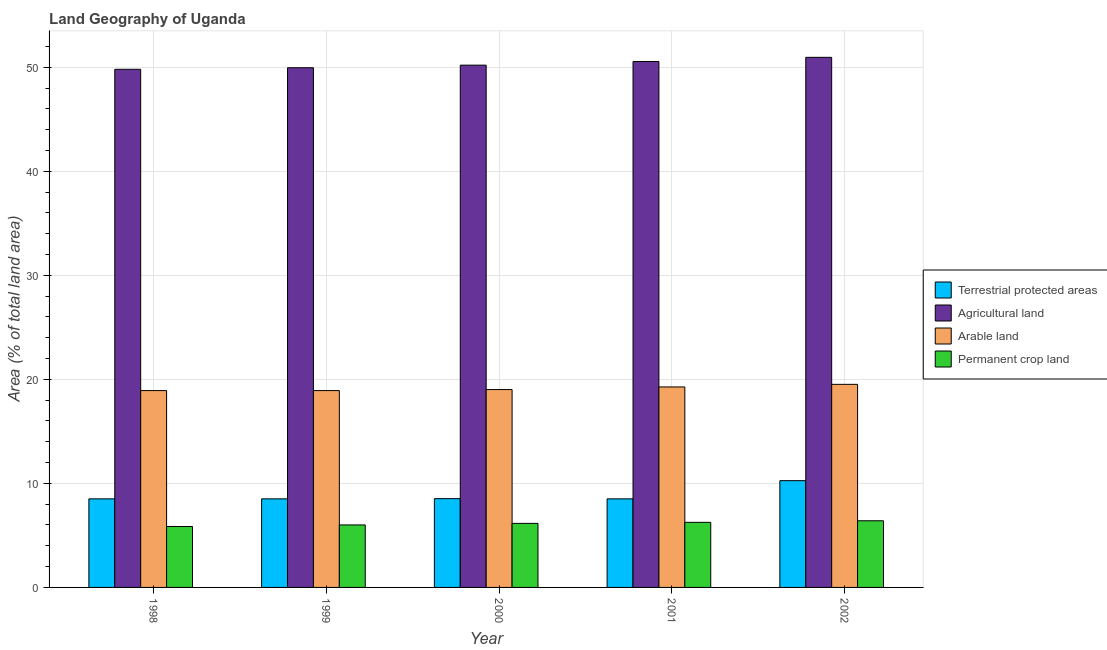How many different coloured bars are there?
Provide a short and direct response. 4. How many groups of bars are there?
Offer a very short reply. 5. Are the number of bars per tick equal to the number of legend labels?
Your answer should be very brief. Yes. How many bars are there on the 3rd tick from the left?
Keep it short and to the point. 4. How many bars are there on the 1st tick from the right?
Provide a short and direct response. 4. In how many cases, is the number of bars for a given year not equal to the number of legend labels?
Offer a very short reply. 0. What is the percentage of area under agricultural land in 2002?
Give a very brief answer. 50.95. Across all years, what is the maximum percentage of land under terrestrial protection?
Provide a succinct answer. 10.26. Across all years, what is the minimum percentage of area under agricultural land?
Keep it short and to the point. 49.8. What is the total percentage of area under permanent crop land in the graph?
Make the answer very short. 30.68. What is the difference between the percentage of land under terrestrial protection in 1998 and that in 2002?
Provide a succinct answer. -1.75. What is the difference between the percentage of land under terrestrial protection in 2001 and the percentage of area under agricultural land in 2000?
Your response must be concise. -0.02. What is the average percentage of area under arable land per year?
Provide a succinct answer. 19.13. In the year 2001, what is the difference between the percentage of area under permanent crop land and percentage of area under arable land?
Give a very brief answer. 0. What is the ratio of the percentage of land under terrestrial protection in 1998 to that in 1999?
Your response must be concise. 1. What is the difference between the highest and the second highest percentage of land under terrestrial protection?
Offer a terse response. 1.73. What is the difference between the highest and the lowest percentage of land under terrestrial protection?
Offer a terse response. 1.75. What does the 3rd bar from the left in 2000 represents?
Ensure brevity in your answer.  Arable land. What does the 3rd bar from the right in 2000 represents?
Give a very brief answer. Agricultural land. Are all the bars in the graph horizontal?
Make the answer very short. No. What is the difference between two consecutive major ticks on the Y-axis?
Offer a very short reply. 10. Does the graph contain any zero values?
Offer a very short reply. No. Does the graph contain grids?
Give a very brief answer. Yes. What is the title of the graph?
Ensure brevity in your answer.  Land Geography of Uganda. What is the label or title of the X-axis?
Make the answer very short. Year. What is the label or title of the Y-axis?
Your answer should be compact. Area (% of total land area). What is the Area (% of total land area) in Terrestrial protected areas in 1998?
Make the answer very short. 8.51. What is the Area (% of total land area) in Agricultural land in 1998?
Offer a terse response. 49.8. What is the Area (% of total land area) in Arable land in 1998?
Provide a short and direct response. 18.92. What is the Area (% of total land area) of Permanent crop land in 1998?
Ensure brevity in your answer.  5.86. What is the Area (% of total land area) of Terrestrial protected areas in 1999?
Offer a very short reply. 8.51. What is the Area (% of total land area) in Agricultural land in 1999?
Give a very brief answer. 49.95. What is the Area (% of total land area) of Arable land in 1999?
Offer a very short reply. 18.92. What is the Area (% of total land area) of Permanent crop land in 1999?
Your answer should be very brief. 6.01. What is the Area (% of total land area) of Terrestrial protected areas in 2000?
Keep it short and to the point. 8.53. What is the Area (% of total land area) in Agricultural land in 2000?
Provide a succinct answer. 50.2. What is the Area (% of total land area) of Arable land in 2000?
Your answer should be compact. 19.02. What is the Area (% of total land area) of Permanent crop land in 2000?
Offer a terse response. 6.16. What is the Area (% of total land area) in Terrestrial protected areas in 2001?
Keep it short and to the point. 8.51. What is the Area (% of total land area) in Agricultural land in 2001?
Provide a short and direct response. 50.55. What is the Area (% of total land area) of Arable land in 2001?
Your answer should be very brief. 19.27. What is the Area (% of total land area) in Permanent crop land in 2001?
Keep it short and to the point. 6.26. What is the Area (% of total land area) of Terrestrial protected areas in 2002?
Your answer should be very brief. 10.26. What is the Area (% of total land area) in Agricultural land in 2002?
Provide a short and direct response. 50.95. What is the Area (% of total land area) of Arable land in 2002?
Keep it short and to the point. 19.52. What is the Area (% of total land area) in Permanent crop land in 2002?
Ensure brevity in your answer.  6.41. Across all years, what is the maximum Area (% of total land area) in Terrestrial protected areas?
Your answer should be compact. 10.26. Across all years, what is the maximum Area (% of total land area) in Agricultural land?
Provide a succinct answer. 50.95. Across all years, what is the maximum Area (% of total land area) in Arable land?
Provide a succinct answer. 19.52. Across all years, what is the maximum Area (% of total land area) in Permanent crop land?
Give a very brief answer. 6.41. Across all years, what is the minimum Area (% of total land area) of Terrestrial protected areas?
Ensure brevity in your answer.  8.51. Across all years, what is the minimum Area (% of total land area) of Agricultural land?
Offer a terse response. 49.8. Across all years, what is the minimum Area (% of total land area) of Arable land?
Provide a short and direct response. 18.92. Across all years, what is the minimum Area (% of total land area) of Permanent crop land?
Your answer should be compact. 5.86. What is the total Area (% of total land area) in Terrestrial protected areas in the graph?
Your answer should be very brief. 44.33. What is the total Area (% of total land area) of Agricultural land in the graph?
Offer a very short reply. 251.44. What is the total Area (% of total land area) in Arable land in the graph?
Offer a very short reply. 95.64. What is the total Area (% of total land area) of Permanent crop land in the graph?
Offer a very short reply. 30.68. What is the difference between the Area (% of total land area) in Terrestrial protected areas in 1998 and that in 1999?
Offer a very short reply. 0. What is the difference between the Area (% of total land area) in Agricultural land in 1998 and that in 1999?
Make the answer very short. -0.15. What is the difference between the Area (% of total land area) in Arable land in 1998 and that in 1999?
Your response must be concise. 0. What is the difference between the Area (% of total land area) in Permanent crop land in 1998 and that in 1999?
Make the answer very short. -0.15. What is the difference between the Area (% of total land area) in Terrestrial protected areas in 1998 and that in 2000?
Keep it short and to the point. -0.02. What is the difference between the Area (% of total land area) of Agricultural land in 1998 and that in 2000?
Offer a very short reply. -0.4. What is the difference between the Area (% of total land area) of Arable land in 1998 and that in 2000?
Your answer should be compact. -0.1. What is the difference between the Area (% of total land area) in Permanent crop land in 1998 and that in 2000?
Provide a succinct answer. -0.3. What is the difference between the Area (% of total land area) in Agricultural land in 1998 and that in 2001?
Give a very brief answer. -0.75. What is the difference between the Area (% of total land area) of Arable land in 1998 and that in 2001?
Provide a succinct answer. -0.35. What is the difference between the Area (% of total land area) in Permanent crop land in 1998 and that in 2001?
Give a very brief answer. -0.4. What is the difference between the Area (% of total land area) in Terrestrial protected areas in 1998 and that in 2002?
Make the answer very short. -1.75. What is the difference between the Area (% of total land area) in Agricultural land in 1998 and that in 2002?
Your answer should be very brief. -1.15. What is the difference between the Area (% of total land area) of Arable land in 1998 and that in 2002?
Make the answer very short. -0.6. What is the difference between the Area (% of total land area) of Permanent crop land in 1998 and that in 2002?
Make the answer very short. -0.55. What is the difference between the Area (% of total land area) in Terrestrial protected areas in 1999 and that in 2000?
Give a very brief answer. -0.02. What is the difference between the Area (% of total land area) in Agricultural land in 1999 and that in 2000?
Ensure brevity in your answer.  -0.25. What is the difference between the Area (% of total land area) in Arable land in 1999 and that in 2000?
Provide a succinct answer. -0.1. What is the difference between the Area (% of total land area) in Permanent crop land in 1999 and that in 2000?
Your answer should be compact. -0.15. What is the difference between the Area (% of total land area) of Terrestrial protected areas in 1999 and that in 2001?
Ensure brevity in your answer.  0. What is the difference between the Area (% of total land area) of Agricultural land in 1999 and that in 2001?
Your answer should be very brief. -0.6. What is the difference between the Area (% of total land area) in Arable land in 1999 and that in 2001?
Your answer should be very brief. -0.35. What is the difference between the Area (% of total land area) in Permanent crop land in 1999 and that in 2001?
Provide a succinct answer. -0.25. What is the difference between the Area (% of total land area) in Terrestrial protected areas in 1999 and that in 2002?
Your answer should be very brief. -1.75. What is the difference between the Area (% of total land area) of Agricultural land in 1999 and that in 2002?
Offer a terse response. -1. What is the difference between the Area (% of total land area) in Arable land in 1999 and that in 2002?
Provide a succinct answer. -0.6. What is the difference between the Area (% of total land area) of Permanent crop land in 1999 and that in 2002?
Your response must be concise. -0.4. What is the difference between the Area (% of total land area) in Terrestrial protected areas in 2000 and that in 2001?
Give a very brief answer. 0.02. What is the difference between the Area (% of total land area) of Agricultural land in 2000 and that in 2001?
Your answer should be very brief. -0.35. What is the difference between the Area (% of total land area) in Arable land in 2000 and that in 2001?
Provide a succinct answer. -0.25. What is the difference between the Area (% of total land area) of Permanent crop land in 2000 and that in 2001?
Your answer should be very brief. -0.1. What is the difference between the Area (% of total land area) in Terrestrial protected areas in 2000 and that in 2002?
Offer a very short reply. -1.73. What is the difference between the Area (% of total land area) in Agricultural land in 2000 and that in 2002?
Provide a short and direct response. -0.75. What is the difference between the Area (% of total land area) of Arable land in 2000 and that in 2002?
Provide a short and direct response. -0.5. What is the difference between the Area (% of total land area) in Permanent crop land in 2000 and that in 2002?
Make the answer very short. -0.25. What is the difference between the Area (% of total land area) of Terrestrial protected areas in 2001 and that in 2002?
Give a very brief answer. -1.75. What is the difference between the Area (% of total land area) in Agricultural land in 2001 and that in 2002?
Your answer should be compact. -0.4. What is the difference between the Area (% of total land area) of Arable land in 2001 and that in 2002?
Offer a very short reply. -0.25. What is the difference between the Area (% of total land area) of Permanent crop land in 2001 and that in 2002?
Give a very brief answer. -0.15. What is the difference between the Area (% of total land area) of Terrestrial protected areas in 1998 and the Area (% of total land area) of Agricultural land in 1999?
Your answer should be very brief. -41.43. What is the difference between the Area (% of total land area) in Terrestrial protected areas in 1998 and the Area (% of total land area) in Arable land in 1999?
Offer a terse response. -10.4. What is the difference between the Area (% of total land area) of Terrestrial protected areas in 1998 and the Area (% of total land area) of Permanent crop land in 1999?
Keep it short and to the point. 2.51. What is the difference between the Area (% of total land area) in Agricultural land in 1998 and the Area (% of total land area) in Arable land in 1999?
Offer a very short reply. 30.88. What is the difference between the Area (% of total land area) in Agricultural land in 1998 and the Area (% of total land area) in Permanent crop land in 1999?
Your answer should be very brief. 43.79. What is the difference between the Area (% of total land area) of Arable land in 1998 and the Area (% of total land area) of Permanent crop land in 1999?
Your answer should be compact. 12.91. What is the difference between the Area (% of total land area) of Terrestrial protected areas in 1998 and the Area (% of total land area) of Agricultural land in 2000?
Your response must be concise. -41.68. What is the difference between the Area (% of total land area) of Terrestrial protected areas in 1998 and the Area (% of total land area) of Arable land in 2000?
Offer a terse response. -10.51. What is the difference between the Area (% of total land area) in Terrestrial protected areas in 1998 and the Area (% of total land area) in Permanent crop land in 2000?
Your answer should be compact. 2.36. What is the difference between the Area (% of total land area) in Agricultural land in 1998 and the Area (% of total land area) in Arable land in 2000?
Keep it short and to the point. 30.78. What is the difference between the Area (% of total land area) of Agricultural land in 1998 and the Area (% of total land area) of Permanent crop land in 2000?
Provide a short and direct response. 43.64. What is the difference between the Area (% of total land area) in Arable land in 1998 and the Area (% of total land area) in Permanent crop land in 2000?
Your answer should be very brief. 12.76. What is the difference between the Area (% of total land area) of Terrestrial protected areas in 1998 and the Area (% of total land area) of Agricultural land in 2001?
Offer a terse response. -42.04. What is the difference between the Area (% of total land area) in Terrestrial protected areas in 1998 and the Area (% of total land area) in Arable land in 2001?
Your answer should be very brief. -10.76. What is the difference between the Area (% of total land area) of Terrestrial protected areas in 1998 and the Area (% of total land area) of Permanent crop land in 2001?
Ensure brevity in your answer.  2.26. What is the difference between the Area (% of total land area) of Agricultural land in 1998 and the Area (% of total land area) of Arable land in 2001?
Your answer should be compact. 30.53. What is the difference between the Area (% of total land area) in Agricultural land in 1998 and the Area (% of total land area) in Permanent crop land in 2001?
Your answer should be very brief. 43.54. What is the difference between the Area (% of total land area) in Arable land in 1998 and the Area (% of total land area) in Permanent crop land in 2001?
Make the answer very short. 12.66. What is the difference between the Area (% of total land area) in Terrestrial protected areas in 1998 and the Area (% of total land area) in Agricultural land in 2002?
Your answer should be compact. -42.44. What is the difference between the Area (% of total land area) of Terrestrial protected areas in 1998 and the Area (% of total land area) of Arable land in 2002?
Provide a short and direct response. -11.01. What is the difference between the Area (% of total land area) of Terrestrial protected areas in 1998 and the Area (% of total land area) of Permanent crop land in 2002?
Your answer should be very brief. 2.11. What is the difference between the Area (% of total land area) in Agricultural land in 1998 and the Area (% of total land area) in Arable land in 2002?
Give a very brief answer. 30.28. What is the difference between the Area (% of total land area) in Agricultural land in 1998 and the Area (% of total land area) in Permanent crop land in 2002?
Give a very brief answer. 43.39. What is the difference between the Area (% of total land area) in Arable land in 1998 and the Area (% of total land area) in Permanent crop land in 2002?
Ensure brevity in your answer.  12.51. What is the difference between the Area (% of total land area) in Terrestrial protected areas in 1999 and the Area (% of total land area) in Agricultural land in 2000?
Provide a short and direct response. -41.68. What is the difference between the Area (% of total land area) in Terrestrial protected areas in 1999 and the Area (% of total land area) in Arable land in 2000?
Your answer should be very brief. -10.51. What is the difference between the Area (% of total land area) of Terrestrial protected areas in 1999 and the Area (% of total land area) of Permanent crop land in 2000?
Provide a short and direct response. 2.36. What is the difference between the Area (% of total land area) in Agricultural land in 1999 and the Area (% of total land area) in Arable land in 2000?
Keep it short and to the point. 30.93. What is the difference between the Area (% of total land area) in Agricultural land in 1999 and the Area (% of total land area) in Permanent crop land in 2000?
Provide a succinct answer. 43.79. What is the difference between the Area (% of total land area) in Arable land in 1999 and the Area (% of total land area) in Permanent crop land in 2000?
Offer a terse response. 12.76. What is the difference between the Area (% of total land area) of Terrestrial protected areas in 1999 and the Area (% of total land area) of Agricultural land in 2001?
Make the answer very short. -42.04. What is the difference between the Area (% of total land area) in Terrestrial protected areas in 1999 and the Area (% of total land area) in Arable land in 2001?
Your answer should be very brief. -10.76. What is the difference between the Area (% of total land area) in Terrestrial protected areas in 1999 and the Area (% of total land area) in Permanent crop land in 2001?
Ensure brevity in your answer.  2.26. What is the difference between the Area (% of total land area) in Agricultural land in 1999 and the Area (% of total land area) in Arable land in 2001?
Provide a succinct answer. 30.68. What is the difference between the Area (% of total land area) in Agricultural land in 1999 and the Area (% of total land area) in Permanent crop land in 2001?
Offer a terse response. 43.69. What is the difference between the Area (% of total land area) in Arable land in 1999 and the Area (% of total land area) in Permanent crop land in 2001?
Provide a succinct answer. 12.66. What is the difference between the Area (% of total land area) of Terrestrial protected areas in 1999 and the Area (% of total land area) of Agricultural land in 2002?
Your answer should be compact. -42.44. What is the difference between the Area (% of total land area) in Terrestrial protected areas in 1999 and the Area (% of total land area) in Arable land in 2002?
Your response must be concise. -11.01. What is the difference between the Area (% of total land area) in Terrestrial protected areas in 1999 and the Area (% of total land area) in Permanent crop land in 2002?
Provide a succinct answer. 2.11. What is the difference between the Area (% of total land area) in Agricultural land in 1999 and the Area (% of total land area) in Arable land in 2002?
Your response must be concise. 30.43. What is the difference between the Area (% of total land area) of Agricultural land in 1999 and the Area (% of total land area) of Permanent crop land in 2002?
Provide a succinct answer. 43.54. What is the difference between the Area (% of total land area) in Arable land in 1999 and the Area (% of total land area) in Permanent crop land in 2002?
Provide a short and direct response. 12.51. What is the difference between the Area (% of total land area) of Terrestrial protected areas in 2000 and the Area (% of total land area) of Agricultural land in 2001?
Your response must be concise. -42.02. What is the difference between the Area (% of total land area) of Terrestrial protected areas in 2000 and the Area (% of total land area) of Arable land in 2001?
Your answer should be very brief. -10.74. What is the difference between the Area (% of total land area) of Terrestrial protected areas in 2000 and the Area (% of total land area) of Permanent crop land in 2001?
Offer a very short reply. 2.28. What is the difference between the Area (% of total land area) of Agricultural land in 2000 and the Area (% of total land area) of Arable land in 2001?
Your response must be concise. 30.93. What is the difference between the Area (% of total land area) of Agricultural land in 2000 and the Area (% of total land area) of Permanent crop land in 2001?
Offer a terse response. 43.94. What is the difference between the Area (% of total land area) of Arable land in 2000 and the Area (% of total land area) of Permanent crop land in 2001?
Give a very brief answer. 12.76. What is the difference between the Area (% of total land area) of Terrestrial protected areas in 2000 and the Area (% of total land area) of Agricultural land in 2002?
Give a very brief answer. -42.42. What is the difference between the Area (% of total land area) in Terrestrial protected areas in 2000 and the Area (% of total land area) in Arable land in 2002?
Your answer should be compact. -10.99. What is the difference between the Area (% of total land area) of Terrestrial protected areas in 2000 and the Area (% of total land area) of Permanent crop land in 2002?
Provide a short and direct response. 2.13. What is the difference between the Area (% of total land area) of Agricultural land in 2000 and the Area (% of total land area) of Arable land in 2002?
Offer a terse response. 30.68. What is the difference between the Area (% of total land area) in Agricultural land in 2000 and the Area (% of total land area) in Permanent crop land in 2002?
Provide a short and direct response. 43.79. What is the difference between the Area (% of total land area) of Arable land in 2000 and the Area (% of total land area) of Permanent crop land in 2002?
Offer a terse response. 12.61. What is the difference between the Area (% of total land area) of Terrestrial protected areas in 2001 and the Area (% of total land area) of Agricultural land in 2002?
Make the answer very short. -42.44. What is the difference between the Area (% of total land area) of Terrestrial protected areas in 2001 and the Area (% of total land area) of Arable land in 2002?
Give a very brief answer. -11.01. What is the difference between the Area (% of total land area) in Terrestrial protected areas in 2001 and the Area (% of total land area) in Permanent crop land in 2002?
Offer a very short reply. 2.11. What is the difference between the Area (% of total land area) of Agricultural land in 2001 and the Area (% of total land area) of Arable land in 2002?
Ensure brevity in your answer.  31.03. What is the difference between the Area (% of total land area) of Agricultural land in 2001 and the Area (% of total land area) of Permanent crop land in 2002?
Provide a short and direct response. 44.14. What is the difference between the Area (% of total land area) of Arable land in 2001 and the Area (% of total land area) of Permanent crop land in 2002?
Offer a very short reply. 12.86. What is the average Area (% of total land area) of Terrestrial protected areas per year?
Your response must be concise. 8.87. What is the average Area (% of total land area) in Agricultural land per year?
Ensure brevity in your answer.  50.29. What is the average Area (% of total land area) in Arable land per year?
Offer a terse response. 19.13. What is the average Area (% of total land area) of Permanent crop land per year?
Your answer should be compact. 6.14. In the year 1998, what is the difference between the Area (% of total land area) of Terrestrial protected areas and Area (% of total land area) of Agricultural land?
Give a very brief answer. -41.28. In the year 1998, what is the difference between the Area (% of total land area) of Terrestrial protected areas and Area (% of total land area) of Arable land?
Make the answer very short. -10.4. In the year 1998, what is the difference between the Area (% of total land area) of Terrestrial protected areas and Area (% of total land area) of Permanent crop land?
Your response must be concise. 2.66. In the year 1998, what is the difference between the Area (% of total land area) of Agricultural land and Area (% of total land area) of Arable land?
Provide a succinct answer. 30.88. In the year 1998, what is the difference between the Area (% of total land area) in Agricultural land and Area (% of total land area) in Permanent crop land?
Give a very brief answer. 43.94. In the year 1998, what is the difference between the Area (% of total land area) in Arable land and Area (% of total land area) in Permanent crop land?
Ensure brevity in your answer.  13.06. In the year 1999, what is the difference between the Area (% of total land area) of Terrestrial protected areas and Area (% of total land area) of Agricultural land?
Give a very brief answer. -41.43. In the year 1999, what is the difference between the Area (% of total land area) of Terrestrial protected areas and Area (% of total land area) of Arable land?
Provide a short and direct response. -10.4. In the year 1999, what is the difference between the Area (% of total land area) in Terrestrial protected areas and Area (% of total land area) in Permanent crop land?
Offer a terse response. 2.51. In the year 1999, what is the difference between the Area (% of total land area) in Agricultural land and Area (% of total land area) in Arable land?
Your answer should be very brief. 31.03. In the year 1999, what is the difference between the Area (% of total land area) of Agricultural land and Area (% of total land area) of Permanent crop land?
Offer a very short reply. 43.94. In the year 1999, what is the difference between the Area (% of total land area) in Arable land and Area (% of total land area) in Permanent crop land?
Ensure brevity in your answer.  12.91. In the year 2000, what is the difference between the Area (% of total land area) of Terrestrial protected areas and Area (% of total land area) of Agricultural land?
Provide a short and direct response. -41.67. In the year 2000, what is the difference between the Area (% of total land area) in Terrestrial protected areas and Area (% of total land area) in Arable land?
Your response must be concise. -10.49. In the year 2000, what is the difference between the Area (% of total land area) in Terrestrial protected areas and Area (% of total land area) in Permanent crop land?
Offer a very short reply. 2.38. In the year 2000, what is the difference between the Area (% of total land area) of Agricultural land and Area (% of total land area) of Arable land?
Ensure brevity in your answer.  31.18. In the year 2000, what is the difference between the Area (% of total land area) of Agricultural land and Area (% of total land area) of Permanent crop land?
Ensure brevity in your answer.  44.04. In the year 2000, what is the difference between the Area (% of total land area) of Arable land and Area (% of total land area) of Permanent crop land?
Offer a terse response. 12.86. In the year 2001, what is the difference between the Area (% of total land area) of Terrestrial protected areas and Area (% of total land area) of Agricultural land?
Make the answer very short. -42.04. In the year 2001, what is the difference between the Area (% of total land area) in Terrestrial protected areas and Area (% of total land area) in Arable land?
Keep it short and to the point. -10.76. In the year 2001, what is the difference between the Area (% of total land area) in Terrestrial protected areas and Area (% of total land area) in Permanent crop land?
Offer a very short reply. 2.26. In the year 2001, what is the difference between the Area (% of total land area) in Agricultural land and Area (% of total land area) in Arable land?
Your response must be concise. 31.28. In the year 2001, what is the difference between the Area (% of total land area) in Agricultural land and Area (% of total land area) in Permanent crop land?
Your answer should be very brief. 44.29. In the year 2001, what is the difference between the Area (% of total land area) in Arable land and Area (% of total land area) in Permanent crop land?
Your answer should be compact. 13.01. In the year 2002, what is the difference between the Area (% of total land area) in Terrestrial protected areas and Area (% of total land area) in Agricultural land?
Offer a terse response. -40.69. In the year 2002, what is the difference between the Area (% of total land area) of Terrestrial protected areas and Area (% of total land area) of Arable land?
Ensure brevity in your answer.  -9.26. In the year 2002, what is the difference between the Area (% of total land area) of Terrestrial protected areas and Area (% of total land area) of Permanent crop land?
Your response must be concise. 3.85. In the year 2002, what is the difference between the Area (% of total land area) in Agricultural land and Area (% of total land area) in Arable land?
Keep it short and to the point. 31.43. In the year 2002, what is the difference between the Area (% of total land area) in Agricultural land and Area (% of total land area) in Permanent crop land?
Make the answer very short. 44.54. In the year 2002, what is the difference between the Area (% of total land area) of Arable land and Area (% of total land area) of Permanent crop land?
Provide a succinct answer. 13.11. What is the ratio of the Area (% of total land area) in Terrestrial protected areas in 1998 to that in 1999?
Provide a short and direct response. 1. What is the ratio of the Area (% of total land area) of Agricultural land in 1998 to that in 1999?
Make the answer very short. 1. What is the ratio of the Area (% of total land area) in Arable land in 1998 to that in 1999?
Your response must be concise. 1. What is the ratio of the Area (% of total land area) in Permanent crop land in 1998 to that in 1999?
Give a very brief answer. 0.97. What is the ratio of the Area (% of total land area) of Agricultural land in 1998 to that in 2000?
Your answer should be compact. 0.99. What is the ratio of the Area (% of total land area) in Arable land in 1998 to that in 2000?
Keep it short and to the point. 0.99. What is the ratio of the Area (% of total land area) of Permanent crop land in 1998 to that in 2000?
Your response must be concise. 0.95. What is the ratio of the Area (% of total land area) of Agricultural land in 1998 to that in 2001?
Provide a short and direct response. 0.99. What is the ratio of the Area (% of total land area) of Arable land in 1998 to that in 2001?
Your answer should be compact. 0.98. What is the ratio of the Area (% of total land area) of Permanent crop land in 1998 to that in 2001?
Make the answer very short. 0.94. What is the ratio of the Area (% of total land area) of Terrestrial protected areas in 1998 to that in 2002?
Make the answer very short. 0.83. What is the ratio of the Area (% of total land area) in Agricultural land in 1998 to that in 2002?
Your answer should be compact. 0.98. What is the ratio of the Area (% of total land area) in Arable land in 1998 to that in 2002?
Give a very brief answer. 0.97. What is the ratio of the Area (% of total land area) of Permanent crop land in 1998 to that in 2002?
Ensure brevity in your answer.  0.91. What is the ratio of the Area (% of total land area) of Terrestrial protected areas in 1999 to that in 2000?
Provide a succinct answer. 1. What is the ratio of the Area (% of total land area) of Permanent crop land in 1999 to that in 2000?
Keep it short and to the point. 0.98. What is the ratio of the Area (% of total land area) in Terrestrial protected areas in 1999 to that in 2001?
Your answer should be compact. 1. What is the ratio of the Area (% of total land area) in Arable land in 1999 to that in 2001?
Ensure brevity in your answer.  0.98. What is the ratio of the Area (% of total land area) in Terrestrial protected areas in 1999 to that in 2002?
Provide a short and direct response. 0.83. What is the ratio of the Area (% of total land area) of Agricultural land in 1999 to that in 2002?
Provide a succinct answer. 0.98. What is the ratio of the Area (% of total land area) in Arable land in 1999 to that in 2002?
Ensure brevity in your answer.  0.97. What is the ratio of the Area (% of total land area) in Terrestrial protected areas in 2000 to that in 2001?
Offer a terse response. 1. What is the ratio of the Area (% of total land area) in Agricultural land in 2000 to that in 2001?
Your answer should be very brief. 0.99. What is the ratio of the Area (% of total land area) in Arable land in 2000 to that in 2001?
Your response must be concise. 0.99. What is the ratio of the Area (% of total land area) in Terrestrial protected areas in 2000 to that in 2002?
Give a very brief answer. 0.83. What is the ratio of the Area (% of total land area) in Arable land in 2000 to that in 2002?
Provide a succinct answer. 0.97. What is the ratio of the Area (% of total land area) in Permanent crop land in 2000 to that in 2002?
Your response must be concise. 0.96. What is the ratio of the Area (% of total land area) in Terrestrial protected areas in 2001 to that in 2002?
Your response must be concise. 0.83. What is the ratio of the Area (% of total land area) in Arable land in 2001 to that in 2002?
Give a very brief answer. 0.99. What is the ratio of the Area (% of total land area) in Permanent crop land in 2001 to that in 2002?
Offer a terse response. 0.98. What is the difference between the highest and the second highest Area (% of total land area) in Terrestrial protected areas?
Provide a short and direct response. 1.73. What is the difference between the highest and the second highest Area (% of total land area) in Agricultural land?
Your answer should be very brief. 0.4. What is the difference between the highest and the second highest Area (% of total land area) in Arable land?
Your answer should be compact. 0.25. What is the difference between the highest and the second highest Area (% of total land area) in Permanent crop land?
Offer a very short reply. 0.15. What is the difference between the highest and the lowest Area (% of total land area) in Terrestrial protected areas?
Make the answer very short. 1.75. What is the difference between the highest and the lowest Area (% of total land area) in Agricultural land?
Offer a terse response. 1.15. What is the difference between the highest and the lowest Area (% of total land area) of Arable land?
Keep it short and to the point. 0.6. What is the difference between the highest and the lowest Area (% of total land area) of Permanent crop land?
Your answer should be very brief. 0.55. 